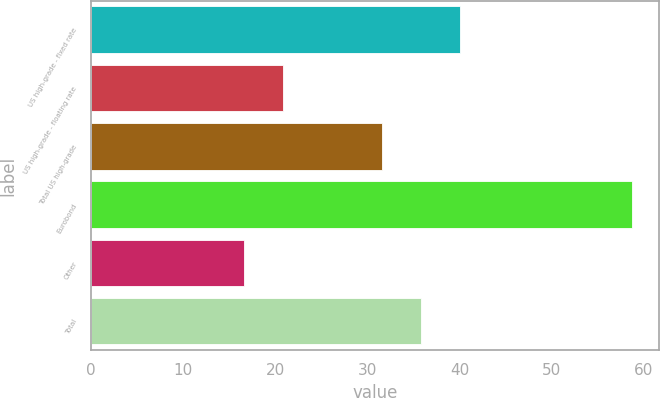Convert chart to OTSL. <chart><loc_0><loc_0><loc_500><loc_500><bar_chart><fcel>US high-grade - fixed rate<fcel>US high-grade - floating rate<fcel>Total US high-grade<fcel>Eurobond<fcel>Other<fcel>Total<nl><fcel>40.02<fcel>20.81<fcel>31.6<fcel>58.7<fcel>16.6<fcel>35.81<nl></chart> 